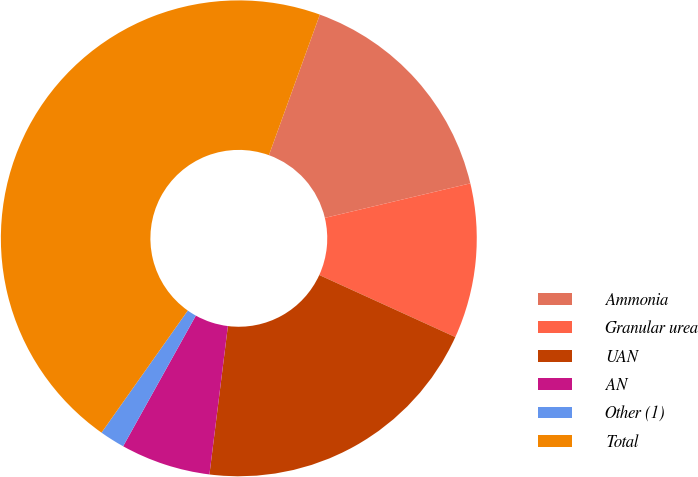<chart> <loc_0><loc_0><loc_500><loc_500><pie_chart><fcel>Ammonia<fcel>Granular urea<fcel>UAN<fcel>AN<fcel>Other (1)<fcel>Total<nl><fcel>15.76%<fcel>10.52%<fcel>20.16%<fcel>6.11%<fcel>1.71%<fcel>45.74%<nl></chart> 